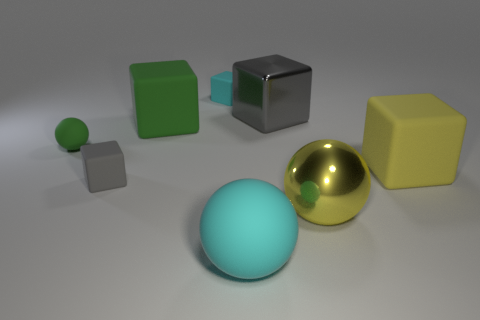Can you describe the largest spherical object and its position relative to the other objects? The largest spherical object in the image is a glossy, reflective gold sphere. It sits centrally among the group of objects, with a yellow cube to its right and a cyan sphere to its left. Its reflective surface stands out against the matte textures of the surrounding items. 